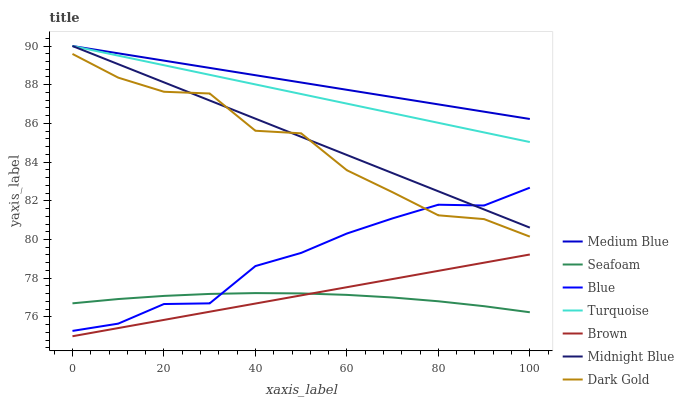Does Seafoam have the minimum area under the curve?
Answer yes or no. Yes. Does Medium Blue have the maximum area under the curve?
Answer yes or no. Yes. Does Brown have the minimum area under the curve?
Answer yes or no. No. Does Brown have the maximum area under the curve?
Answer yes or no. No. Is Turquoise the smoothest?
Answer yes or no. Yes. Is Dark Gold the roughest?
Answer yes or no. Yes. Is Brown the smoothest?
Answer yes or no. No. Is Brown the roughest?
Answer yes or no. No. Does Turquoise have the lowest value?
Answer yes or no. No. Does Medium Blue have the highest value?
Answer yes or no. Yes. Does Brown have the highest value?
Answer yes or no. No. Is Blue less than Medium Blue?
Answer yes or no. Yes. Is Medium Blue greater than Dark Gold?
Answer yes or no. Yes. Does Blue intersect Medium Blue?
Answer yes or no. No. 